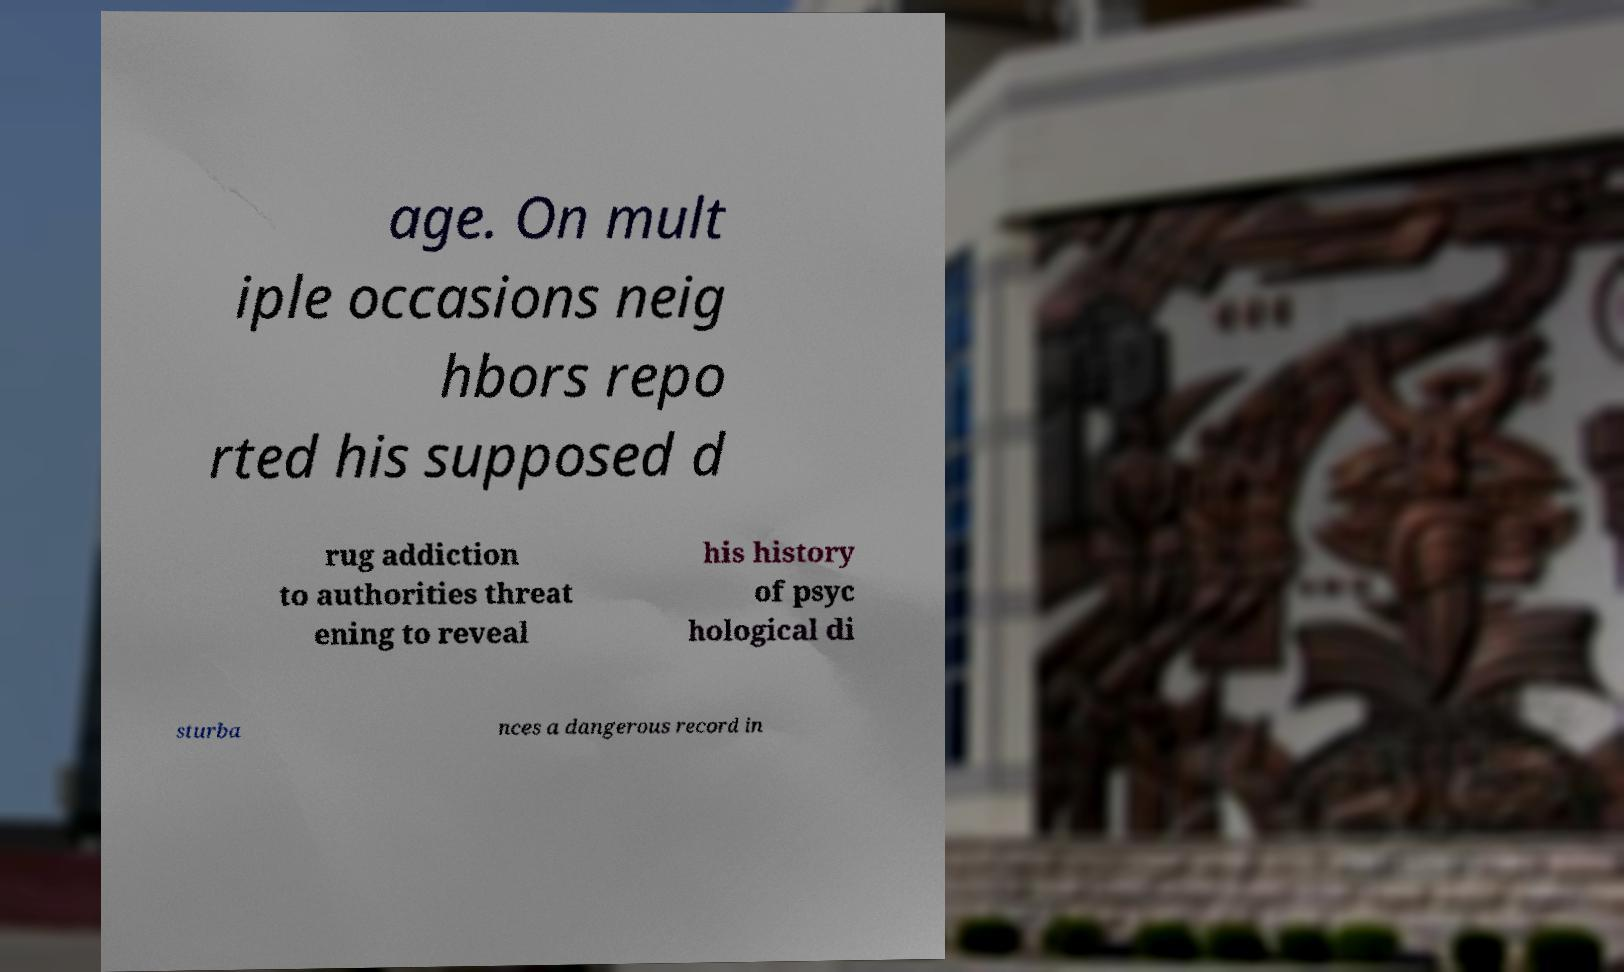For documentation purposes, I need the text within this image transcribed. Could you provide that? age. On mult iple occasions neig hbors repo rted his supposed d rug addiction to authorities threat ening to reveal his history of psyc hological di sturba nces a dangerous record in 